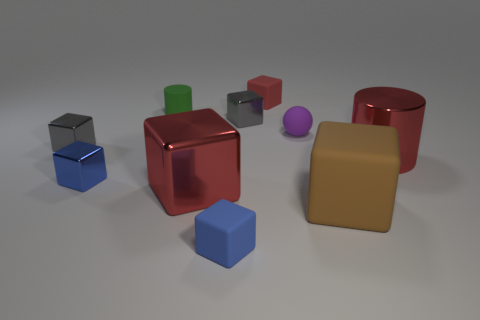Subtract 3 cubes. How many cubes are left? 4 Subtract all big shiny cubes. How many cubes are left? 6 Subtract all blue blocks. How many blocks are left? 5 Subtract all purple blocks. Subtract all brown cylinders. How many blocks are left? 7 Subtract all balls. How many objects are left? 9 Subtract 0 purple cylinders. How many objects are left? 10 Subtract all tiny red rubber cubes. Subtract all tiny rubber cubes. How many objects are left? 7 Add 8 brown objects. How many brown objects are left? 9 Add 1 small brown matte cylinders. How many small brown matte cylinders exist? 1 